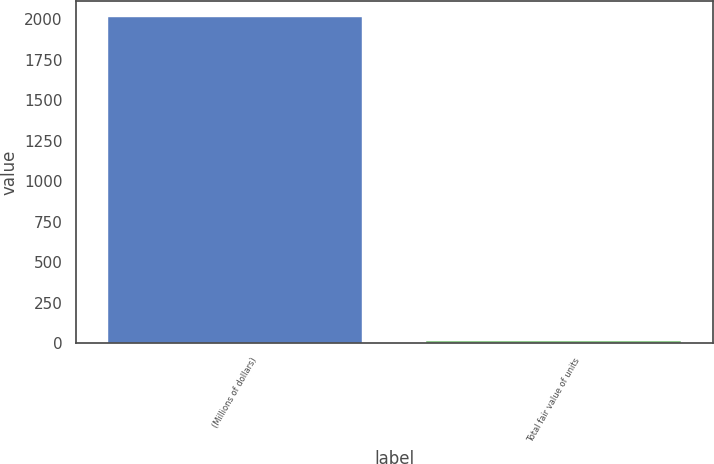Convert chart. <chart><loc_0><loc_0><loc_500><loc_500><bar_chart><fcel>(Millions of dollars)<fcel>Total fair value of units<nl><fcel>2015<fcel>16<nl></chart> 